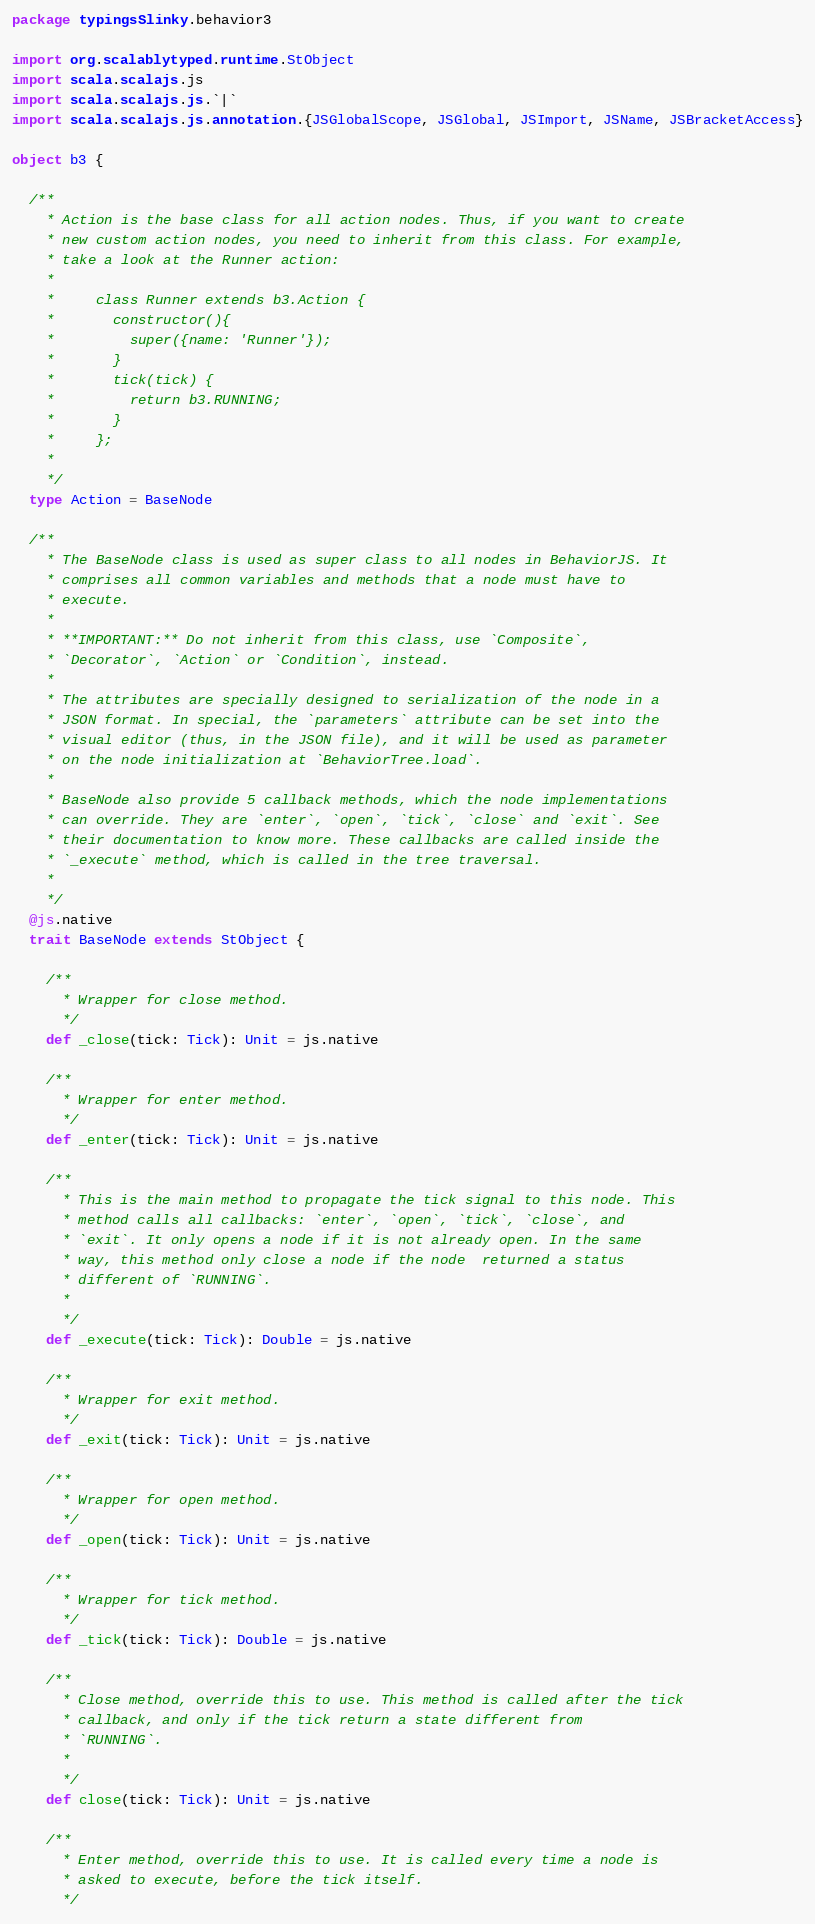<code> <loc_0><loc_0><loc_500><loc_500><_Scala_>package typingsSlinky.behavior3

import org.scalablytyped.runtime.StObject
import scala.scalajs.js
import scala.scalajs.js.`|`
import scala.scalajs.js.annotation.{JSGlobalScope, JSGlobal, JSImport, JSName, JSBracketAccess}

object b3 {
  
  /**
    * Action is the base class for all action nodes. Thus, if you want to create
    * new custom action nodes, you need to inherit from this class. For example,
    * take a look at the Runner action:
    *
    *     class Runner extends b3.Action {
    *       constructor(){
    *         super({name: 'Runner'});
    *       }
    *       tick(tick) {
    *         return b3.RUNNING;
    *       }
    *     };
    *
    */
  type Action = BaseNode
  
  /**
    * The BaseNode class is used as super class to all nodes in BehaviorJS. It
    * comprises all common variables and methods that a node must have to
    * execute.
    *
    * **IMPORTANT:** Do not inherit from this class, use `Composite`,
    * `Decorator`, `Action` or `Condition`, instead.
    *
    * The attributes are specially designed to serialization of the node in a
    * JSON format. In special, the `parameters` attribute can be set into the
    * visual editor (thus, in the JSON file), and it will be used as parameter
    * on the node initialization at `BehaviorTree.load`.
    *
    * BaseNode also provide 5 callback methods, which the node implementations
    * can override. They are `enter`, `open`, `tick`, `close` and `exit`. See
    * their documentation to know more. These callbacks are called inside the
    * `_execute` method, which is called in the tree traversal.
    *
    */
  @js.native
  trait BaseNode extends StObject {
    
    /**
      * Wrapper for close method.
      */
    def _close(tick: Tick): Unit = js.native
    
    /**
      * Wrapper for enter method.
      */
    def _enter(tick: Tick): Unit = js.native
    
    /**
      * This is the main method to propagate the tick signal to this node. This
      * method calls all callbacks: `enter`, `open`, `tick`, `close`, and
      * `exit`. It only opens a node if it is not already open. In the same
      * way, this method only close a node if the node  returned a status
      * different of `RUNNING`.
      *
      */
    def _execute(tick: Tick): Double = js.native
    
    /**
      * Wrapper for exit method.
      */
    def _exit(tick: Tick): Unit = js.native
    
    /**
      * Wrapper for open method.
      */
    def _open(tick: Tick): Unit = js.native
    
    /**
      * Wrapper for tick method.
      */
    def _tick(tick: Tick): Double = js.native
    
    /**
      * Close method, override this to use. This method is called after the tick
      * callback, and only if the tick return a state different from
      * `RUNNING`.
      *
      */
    def close(tick: Tick): Unit = js.native
    
    /**
      * Enter method, override this to use. It is called every time a node is
      * asked to execute, before the tick itself.
      */</code> 